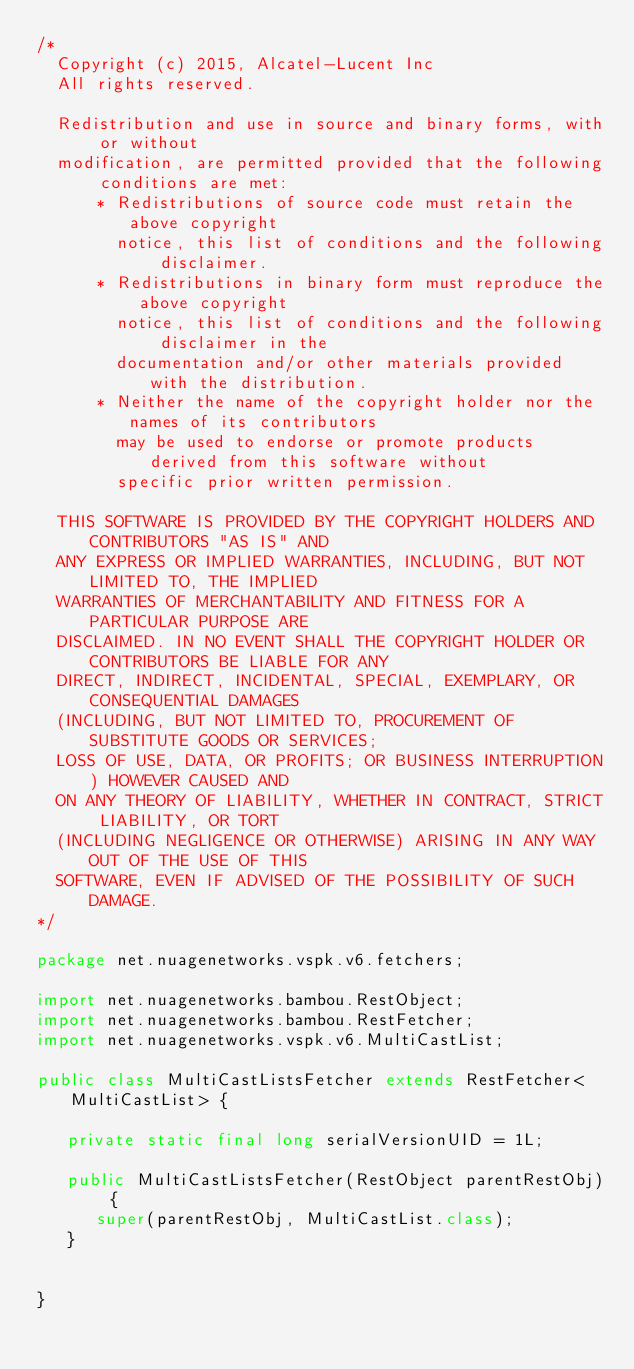<code> <loc_0><loc_0><loc_500><loc_500><_Java_>/*
  Copyright (c) 2015, Alcatel-Lucent Inc
  All rights reserved.

  Redistribution and use in source and binary forms, with or without
  modification, are permitted provided that the following conditions are met:
      * Redistributions of source code must retain the above copyright
        notice, this list of conditions and the following disclaimer.
      * Redistributions in binary form must reproduce the above copyright
        notice, this list of conditions and the following disclaimer in the
        documentation and/or other materials provided with the distribution.
      * Neither the name of the copyright holder nor the names of its contributors
        may be used to endorse or promote products derived from this software without
        specific prior written permission.

  THIS SOFTWARE IS PROVIDED BY THE COPYRIGHT HOLDERS AND CONTRIBUTORS "AS IS" AND
  ANY EXPRESS OR IMPLIED WARRANTIES, INCLUDING, BUT NOT LIMITED TO, THE IMPLIED
  WARRANTIES OF MERCHANTABILITY AND FITNESS FOR A PARTICULAR PURPOSE ARE
  DISCLAIMED. IN NO EVENT SHALL THE COPYRIGHT HOLDER OR CONTRIBUTORS BE LIABLE FOR ANY
  DIRECT, INDIRECT, INCIDENTAL, SPECIAL, EXEMPLARY, OR CONSEQUENTIAL DAMAGES
  (INCLUDING, BUT NOT LIMITED TO, PROCUREMENT OF SUBSTITUTE GOODS OR SERVICES;
  LOSS OF USE, DATA, OR PROFITS; OR BUSINESS INTERRUPTION) HOWEVER CAUSED AND
  ON ANY THEORY OF LIABILITY, WHETHER IN CONTRACT, STRICT LIABILITY, OR TORT
  (INCLUDING NEGLIGENCE OR OTHERWISE) ARISING IN ANY WAY OUT OF THE USE OF THIS
  SOFTWARE, EVEN IF ADVISED OF THE POSSIBILITY OF SUCH DAMAGE.
*/

package net.nuagenetworks.vspk.v6.fetchers;

import net.nuagenetworks.bambou.RestObject;
import net.nuagenetworks.bambou.RestFetcher;
import net.nuagenetworks.vspk.v6.MultiCastList;

public class MultiCastListsFetcher extends RestFetcher<MultiCastList> {

   private static final long serialVersionUID = 1L;
   
   public MultiCastListsFetcher(RestObject parentRestObj) {
      super(parentRestObj, MultiCastList.class);
   }
   
   
}</code> 